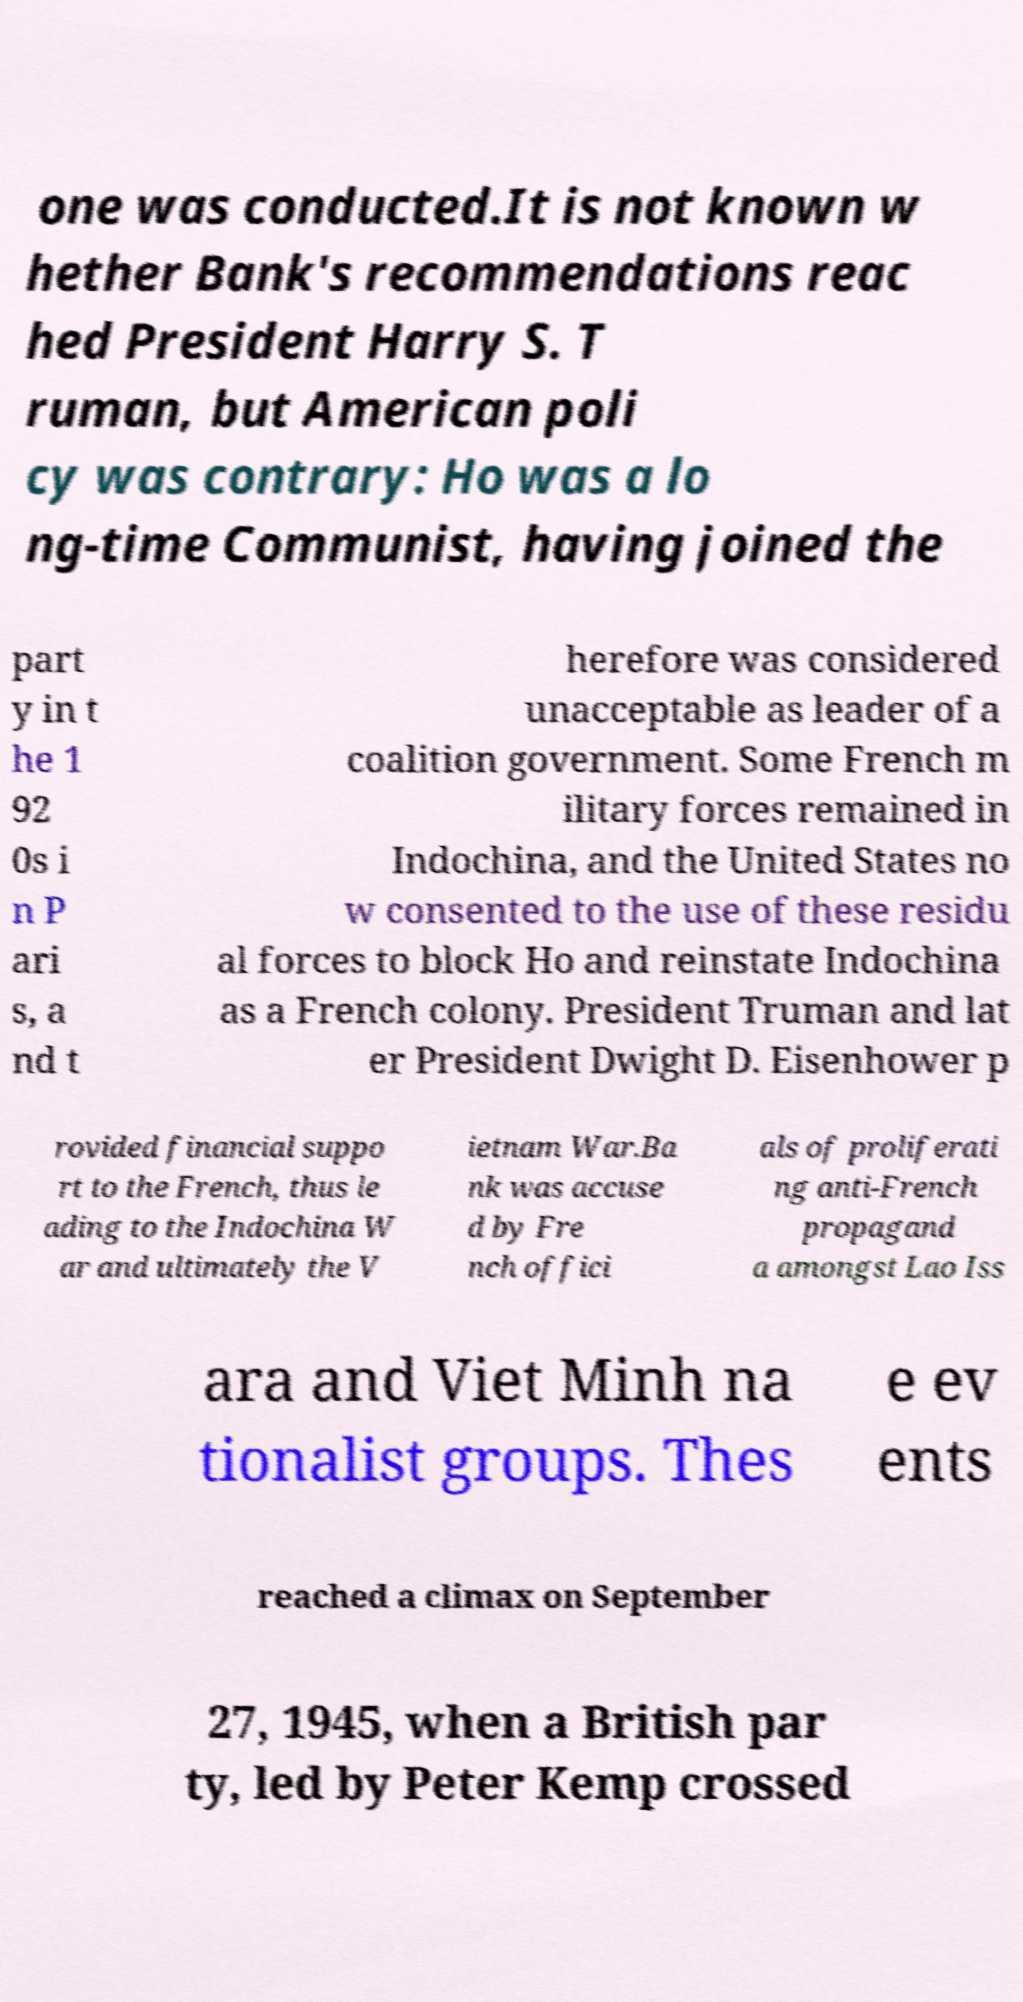Could you assist in decoding the text presented in this image and type it out clearly? one was conducted.It is not known w hether Bank's recommendations reac hed President Harry S. T ruman, but American poli cy was contrary: Ho was a lo ng-time Communist, having joined the part y in t he 1 92 0s i n P ari s, a nd t herefore was considered unacceptable as leader of a coalition government. Some French m ilitary forces remained in Indochina, and the United States no w consented to the use of these residu al forces to block Ho and reinstate Indochina as a French colony. President Truman and lat er President Dwight D. Eisenhower p rovided financial suppo rt to the French, thus le ading to the Indochina W ar and ultimately the V ietnam War.Ba nk was accuse d by Fre nch offici als of proliferati ng anti-French propagand a amongst Lao Iss ara and Viet Minh na tionalist groups. Thes e ev ents reached a climax on September 27, 1945, when a British par ty, led by Peter Kemp crossed 